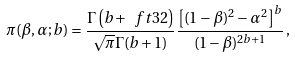<formula> <loc_0><loc_0><loc_500><loc_500>\pi ( \beta , \alpha ; b ) = \frac { { \mathit \Gamma } \left ( b + \ f t 3 2 \right ) } { \sqrt { \pi } { \mathit \Gamma } ( b + 1 ) } \frac { \left [ ( 1 - \beta ) ^ { 2 } - \alpha ^ { 2 } \right ] ^ { b } } { ( 1 - \beta ) ^ { 2 b + 1 } } \, ,</formula> 